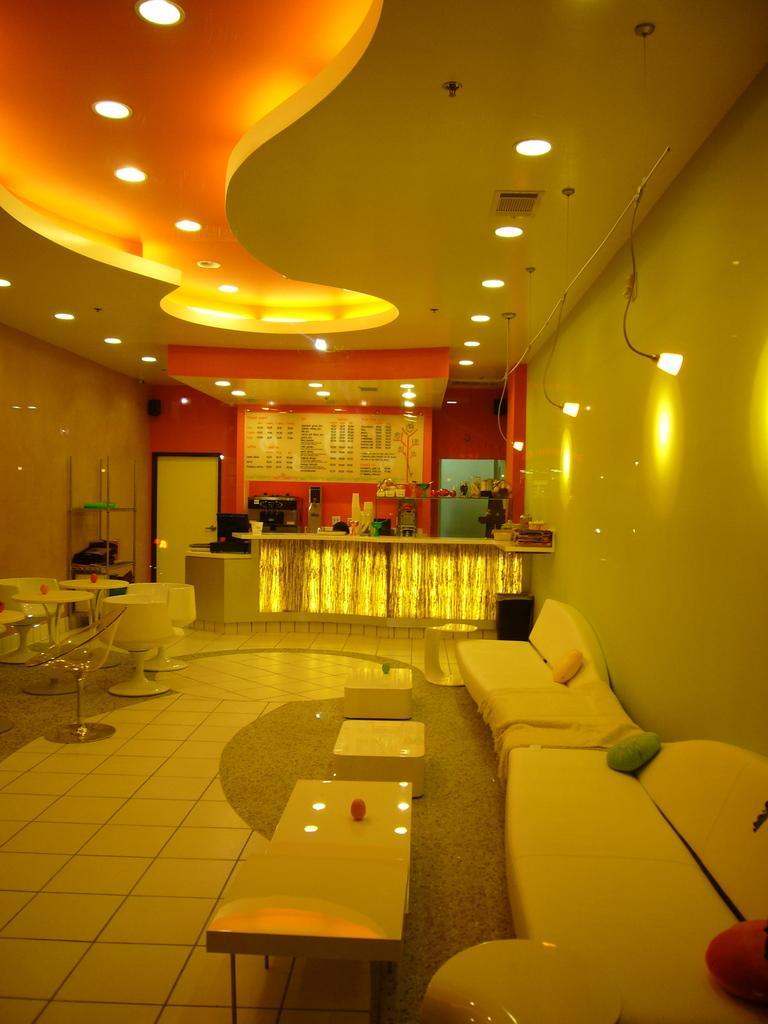Please provide a concise description of this image. In this image on the right side there are chairs, tables, stools, and on the left side also there are some chairs and tables. And in the background there is a reception table, flower pots, and some objects, door, cupboard, wall and some lights. At the top there is ceiling and some lights and objects, at the bottom there is floor and carpet. 